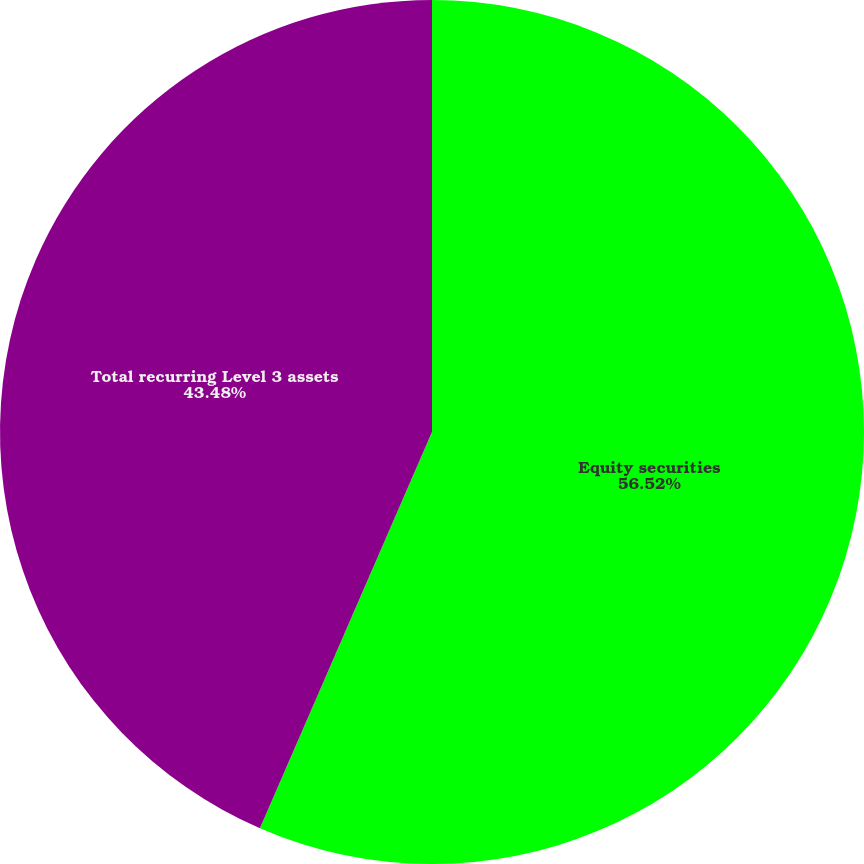<chart> <loc_0><loc_0><loc_500><loc_500><pie_chart><fcel>Equity securities<fcel>Total recurring Level 3 assets<nl><fcel>56.52%<fcel>43.48%<nl></chart> 